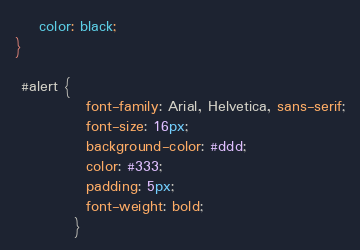Convert code to text. <code><loc_0><loc_0><loc_500><loc_500><_CSS_>    color: black;
}

 #alert {
            font-family: Arial, Helvetica, sans-serif;
            font-size: 16px;
            background-color: #ddd;
            color: #333;
            padding: 5px;
            font-weight: bold;
          }
</code> 